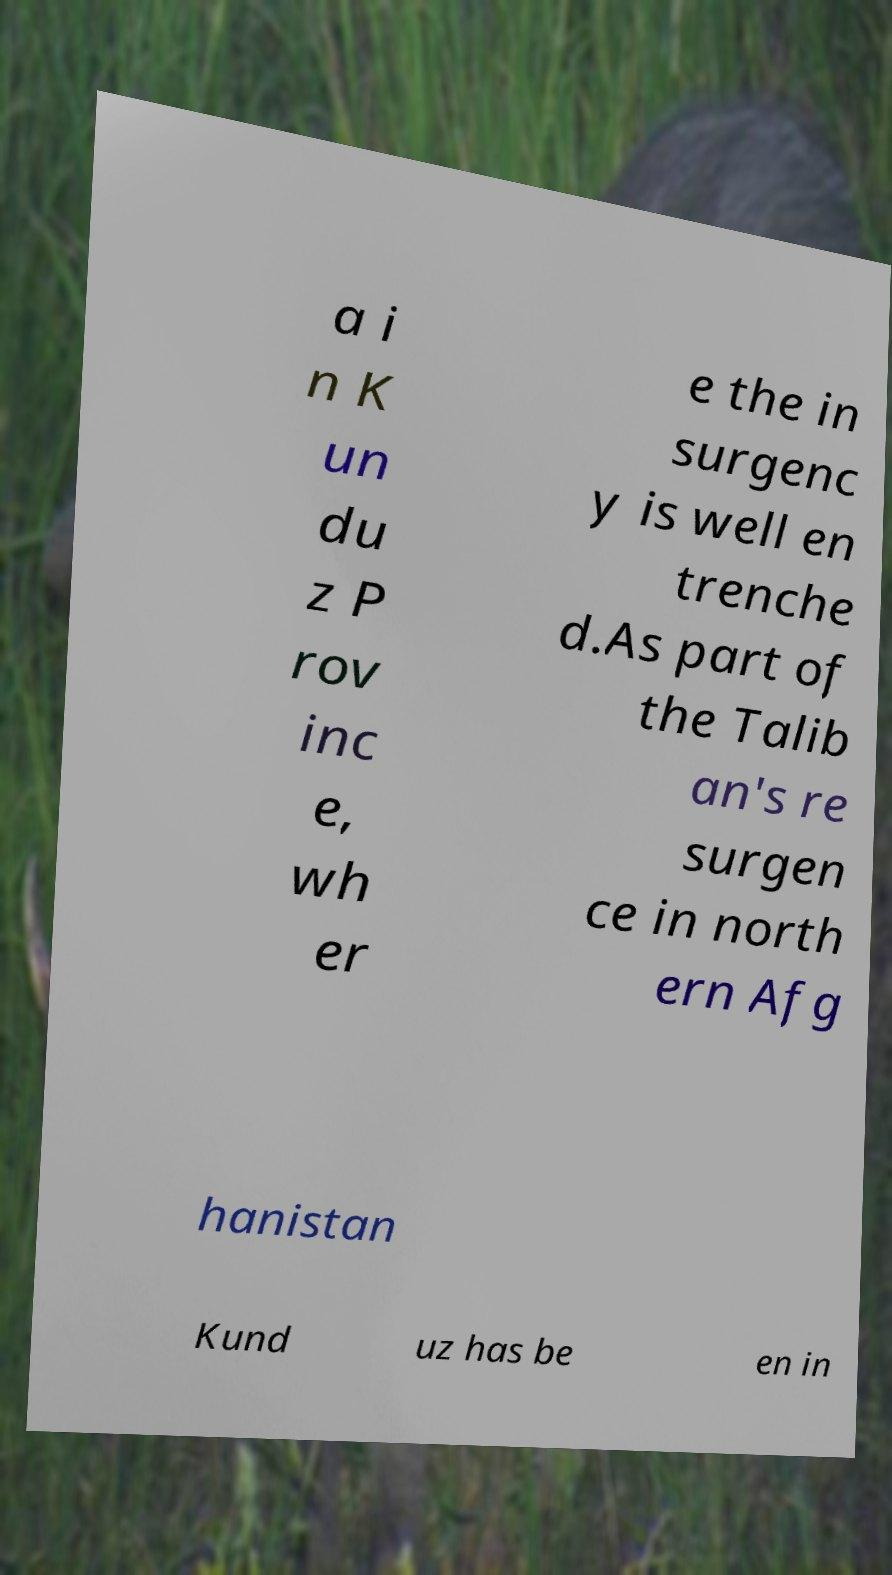Please read and relay the text visible in this image. What does it say? a i n K un du z P rov inc e, wh er e the in surgenc y is well en trenche d.As part of the Talib an's re surgen ce in north ern Afg hanistan Kund uz has be en in 